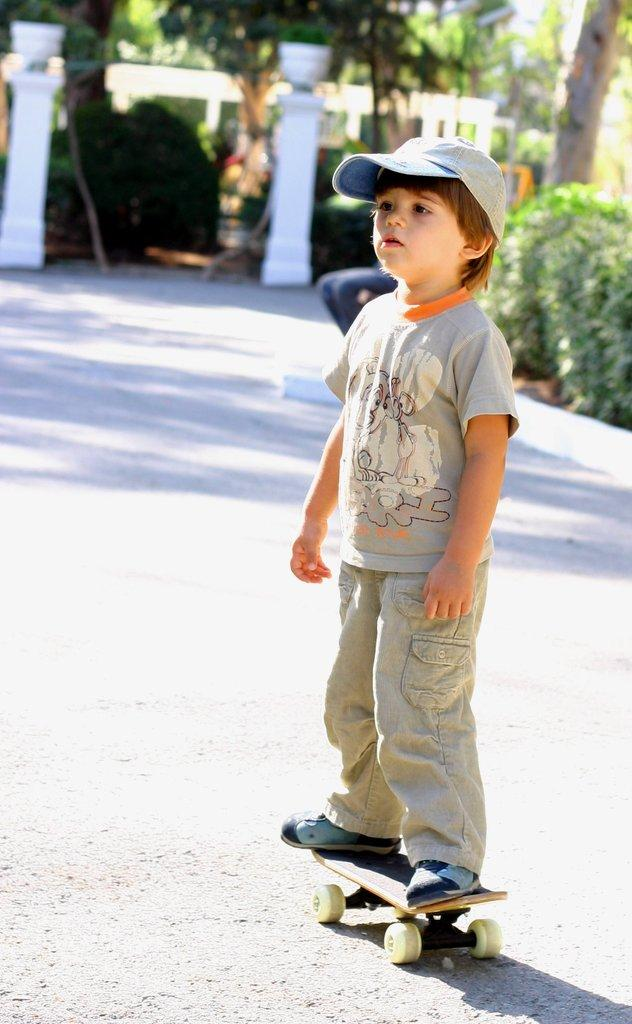What is the main subject of the image? The main subject of the image is a kid. What is the kid doing in the image? The kid is standing on a skateboard. What is the kid wearing in the image? The kid is wearing a hat. What can be seen on the right side of the image? There are plants on the right side of the image. What architectural feature is present in the image? There are white pillars in the image. What type of vegetation is visible in the image? There are trees in the image. Where is the faucet located in the image? There is no faucet present in the image. What type of fish can be seen swimming near the trees in the image? There are no fish visible in the image; it features a kid on a skateboard, plants, white pillars, and trees. 